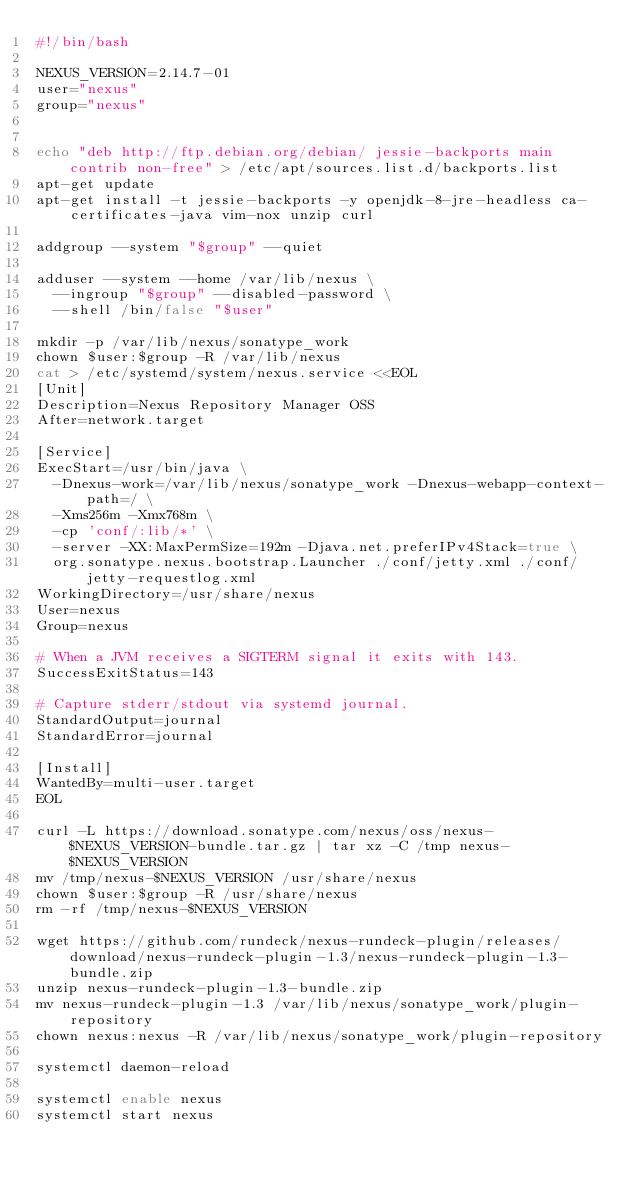Convert code to text. <code><loc_0><loc_0><loc_500><loc_500><_Bash_>#!/bin/bash

NEXUS_VERSION=2.14.7-01
user="nexus"
group="nexus"


echo "deb http://ftp.debian.org/debian/ jessie-backports main contrib non-free" > /etc/apt/sources.list.d/backports.list
apt-get update
apt-get install -t jessie-backports -y openjdk-8-jre-headless ca-certificates-java vim-nox unzip curl

addgroup --system "$group" --quiet

adduser --system --home /var/lib/nexus \
  --ingroup "$group" --disabled-password \
  --shell /bin/false "$user"

mkdir -p /var/lib/nexus/sonatype_work
chown $user:$group -R /var/lib/nexus
cat > /etc/systemd/system/nexus.service <<EOL
[Unit]
Description=Nexus Repository Manager OSS
After=network.target

[Service]
ExecStart=/usr/bin/java \
  -Dnexus-work=/var/lib/nexus/sonatype_work -Dnexus-webapp-context-path=/ \
  -Xms256m -Xmx768m \
  -cp 'conf/:lib/*' \
  -server -XX:MaxPermSize=192m -Djava.net.preferIPv4Stack=true \
  org.sonatype.nexus.bootstrap.Launcher ./conf/jetty.xml ./conf/jetty-requestlog.xml
WorkingDirectory=/usr/share/nexus
User=nexus
Group=nexus

# When a JVM receives a SIGTERM signal it exits with 143.
SuccessExitStatus=143

# Capture stderr/stdout via systemd journal.
StandardOutput=journal
StandardError=journal

[Install]
WantedBy=multi-user.target
EOL

curl -L https://download.sonatype.com/nexus/oss/nexus-$NEXUS_VERSION-bundle.tar.gz | tar xz -C /tmp nexus-$NEXUS_VERSION
mv /tmp/nexus-$NEXUS_VERSION /usr/share/nexus
chown $user:$group -R /usr/share/nexus
rm -rf /tmp/nexus-$NEXUS_VERSION

wget https://github.com/rundeck/nexus-rundeck-plugin/releases/download/nexus-rundeck-plugin-1.3/nexus-rundeck-plugin-1.3-bundle.zip
unzip nexus-rundeck-plugin-1.3-bundle.zip
mv nexus-rundeck-plugin-1.3 /var/lib/nexus/sonatype_work/plugin-repository
chown nexus:nexus -R /var/lib/nexus/sonatype_work/plugin-repository

systemctl daemon-reload

systemctl enable nexus
systemctl start nexus
</code> 